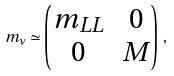<formula> <loc_0><loc_0><loc_500><loc_500>m _ { \nu } \simeq \begin{pmatrix} m _ { L L } & 0 \\ 0 & M \end{pmatrix} \, ,</formula> 